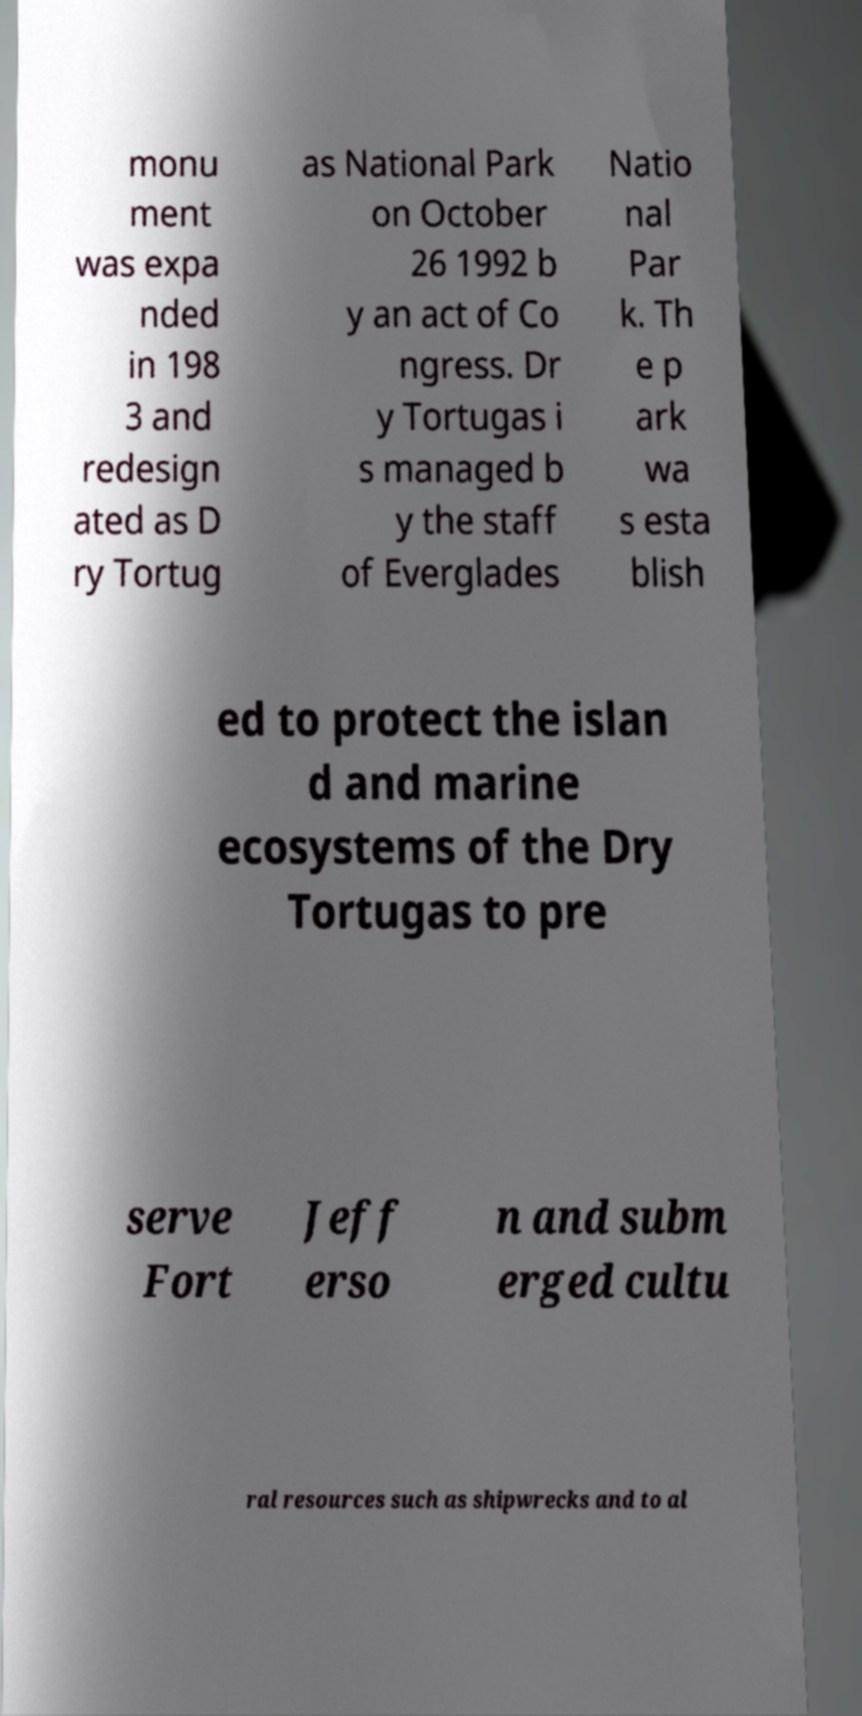Could you extract and type out the text from this image? monu ment was expa nded in 198 3 and redesign ated as D ry Tortug as National Park on October 26 1992 b y an act of Co ngress. Dr y Tortugas i s managed b y the staff of Everglades Natio nal Par k. Th e p ark wa s esta blish ed to protect the islan d and marine ecosystems of the Dry Tortugas to pre serve Fort Jeff erso n and subm erged cultu ral resources such as shipwrecks and to al 